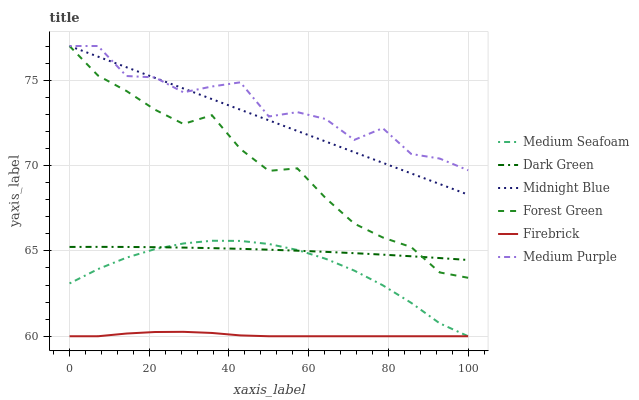Does Medium Purple have the minimum area under the curve?
Answer yes or no. No. Does Firebrick have the maximum area under the curve?
Answer yes or no. No. Is Firebrick the smoothest?
Answer yes or no. No. Is Firebrick the roughest?
Answer yes or no. No. Does Medium Purple have the lowest value?
Answer yes or no. No. Does Firebrick have the highest value?
Answer yes or no. No. Is Medium Seafoam less than Forest Green?
Answer yes or no. Yes. Is Dark Green greater than Firebrick?
Answer yes or no. Yes. Does Medium Seafoam intersect Forest Green?
Answer yes or no. No. 